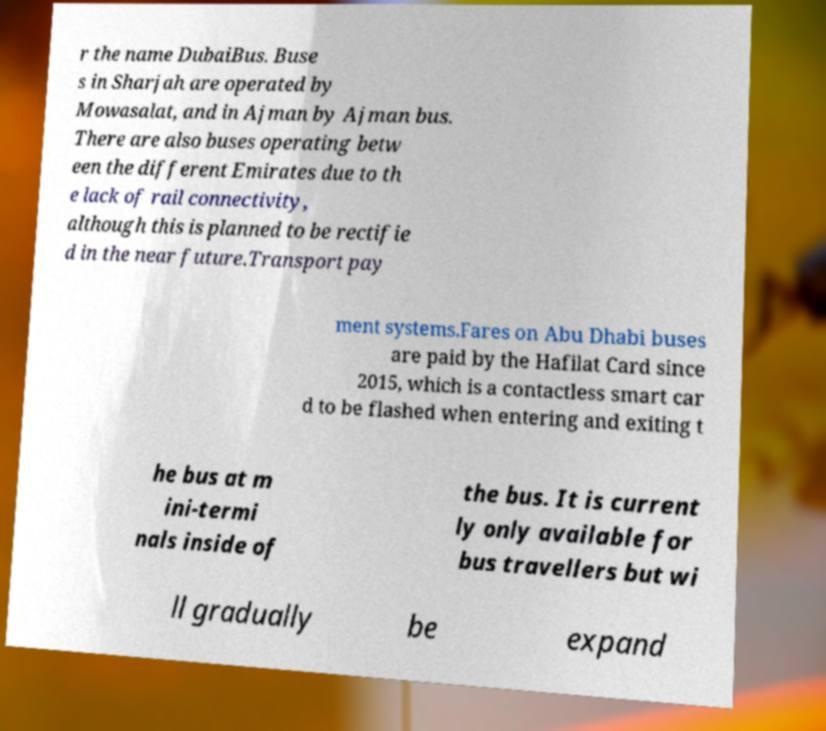Could you extract and type out the text from this image? r the name DubaiBus. Buse s in Sharjah are operated by Mowasalat, and in Ajman by Ajman bus. There are also buses operating betw een the different Emirates due to th e lack of rail connectivity, although this is planned to be rectifie d in the near future.Transport pay ment systems.Fares on Abu Dhabi buses are paid by the Hafilat Card since 2015, which is a contactless smart car d to be flashed when entering and exiting t he bus at m ini-termi nals inside of the bus. It is current ly only available for bus travellers but wi ll gradually be expand 